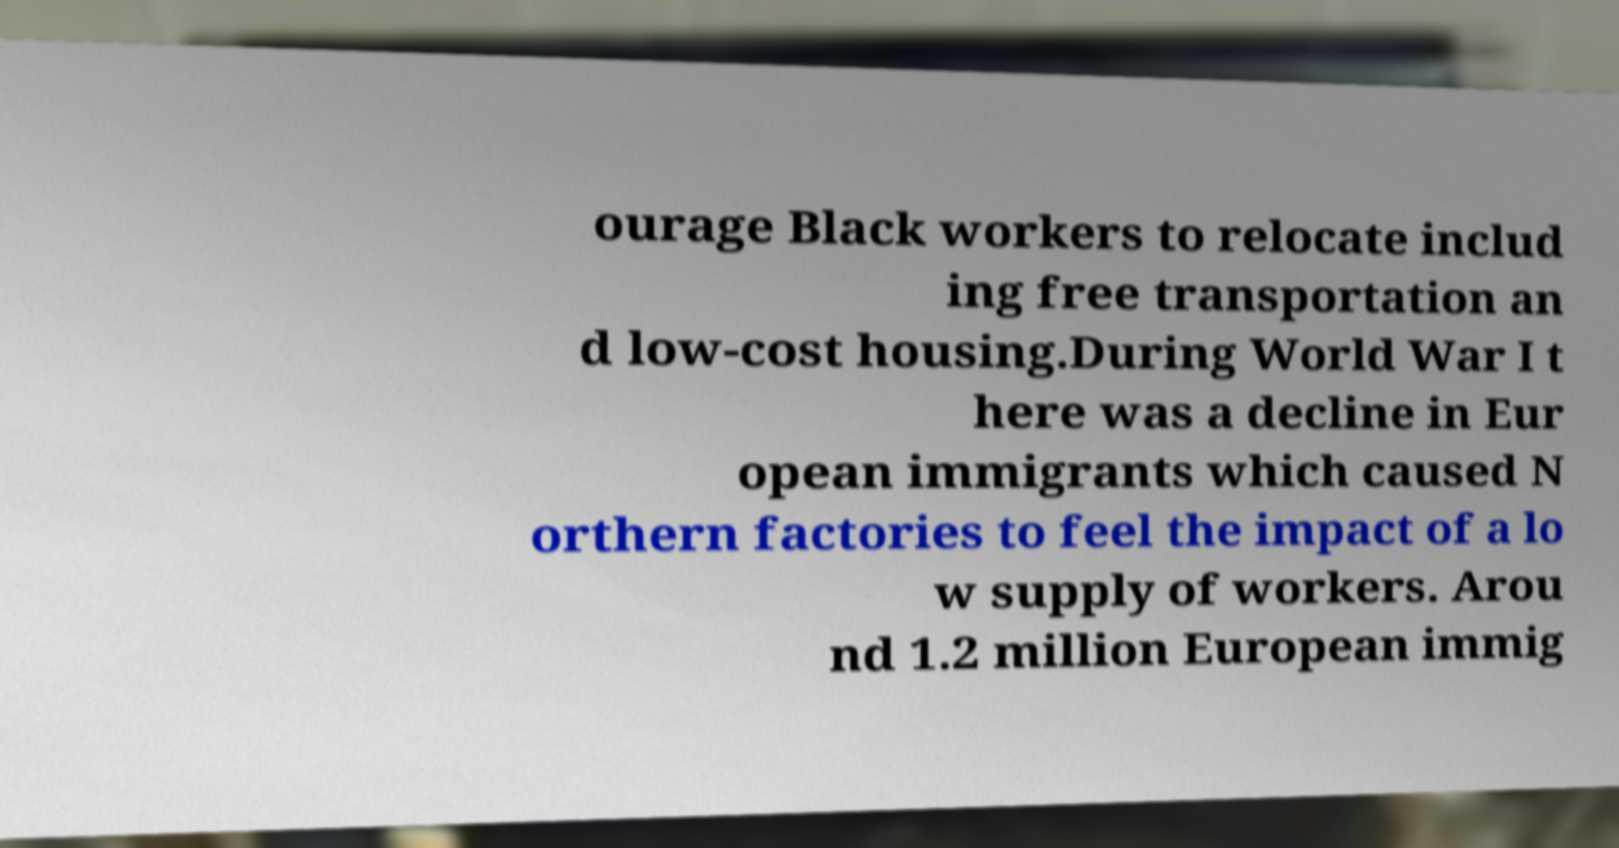Can you accurately transcribe the text from the provided image for me? ourage Black workers to relocate includ ing free transportation an d low-cost housing.During World War I t here was a decline in Eur opean immigrants which caused N orthern factories to feel the impact of a lo w supply of workers. Arou nd 1.2 million European immig 